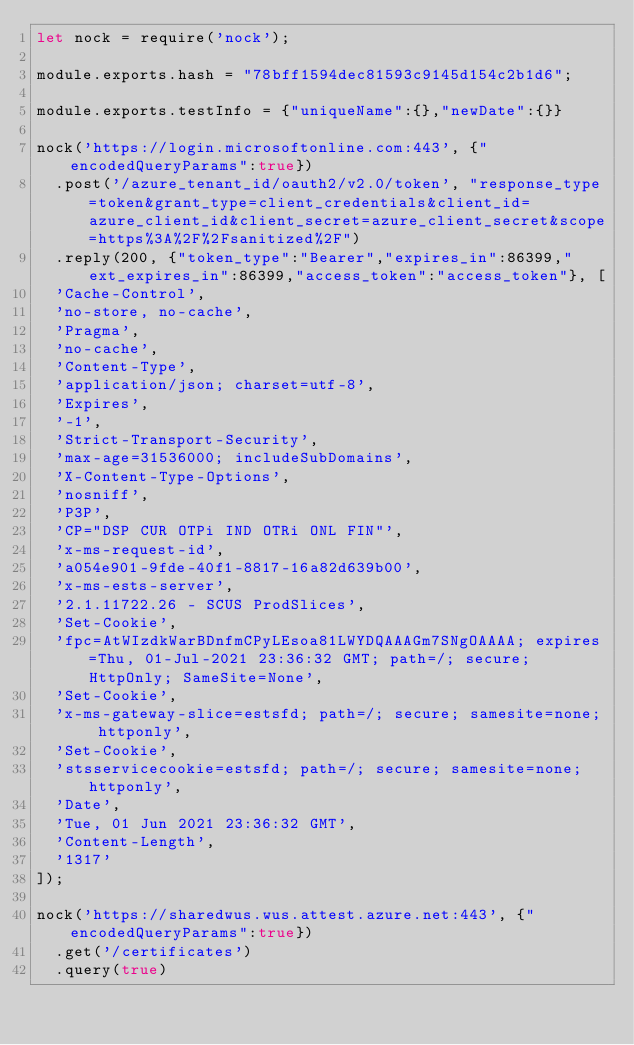<code> <loc_0><loc_0><loc_500><loc_500><_JavaScript_>let nock = require('nock');

module.exports.hash = "78bff1594dec81593c9145d154c2b1d6";

module.exports.testInfo = {"uniqueName":{},"newDate":{}}

nock('https://login.microsoftonline.com:443', {"encodedQueryParams":true})
  .post('/azure_tenant_id/oauth2/v2.0/token', "response_type=token&grant_type=client_credentials&client_id=azure_client_id&client_secret=azure_client_secret&scope=https%3A%2F%2Fsanitized%2F")
  .reply(200, {"token_type":"Bearer","expires_in":86399,"ext_expires_in":86399,"access_token":"access_token"}, [
  'Cache-Control',
  'no-store, no-cache',
  'Pragma',
  'no-cache',
  'Content-Type',
  'application/json; charset=utf-8',
  'Expires',
  '-1',
  'Strict-Transport-Security',
  'max-age=31536000; includeSubDomains',
  'X-Content-Type-Options',
  'nosniff',
  'P3P',
  'CP="DSP CUR OTPi IND OTRi ONL FIN"',
  'x-ms-request-id',
  'a054e901-9fde-40f1-8817-16a82d639b00',
  'x-ms-ests-server',
  '2.1.11722.26 - SCUS ProdSlices',
  'Set-Cookie',
  'fpc=AtWIzdkWarBDnfmCPyLEsoa81LWYDQAAAGm7SNgOAAAA; expires=Thu, 01-Jul-2021 23:36:32 GMT; path=/; secure; HttpOnly; SameSite=None',
  'Set-Cookie',
  'x-ms-gateway-slice=estsfd; path=/; secure; samesite=none; httponly',
  'Set-Cookie',
  'stsservicecookie=estsfd; path=/; secure; samesite=none; httponly',
  'Date',
  'Tue, 01 Jun 2021 23:36:32 GMT',
  'Content-Length',
  '1317'
]);

nock('https://sharedwus.wus.attest.azure.net:443', {"encodedQueryParams":true})
  .get('/certificates')
  .query(true)</code> 